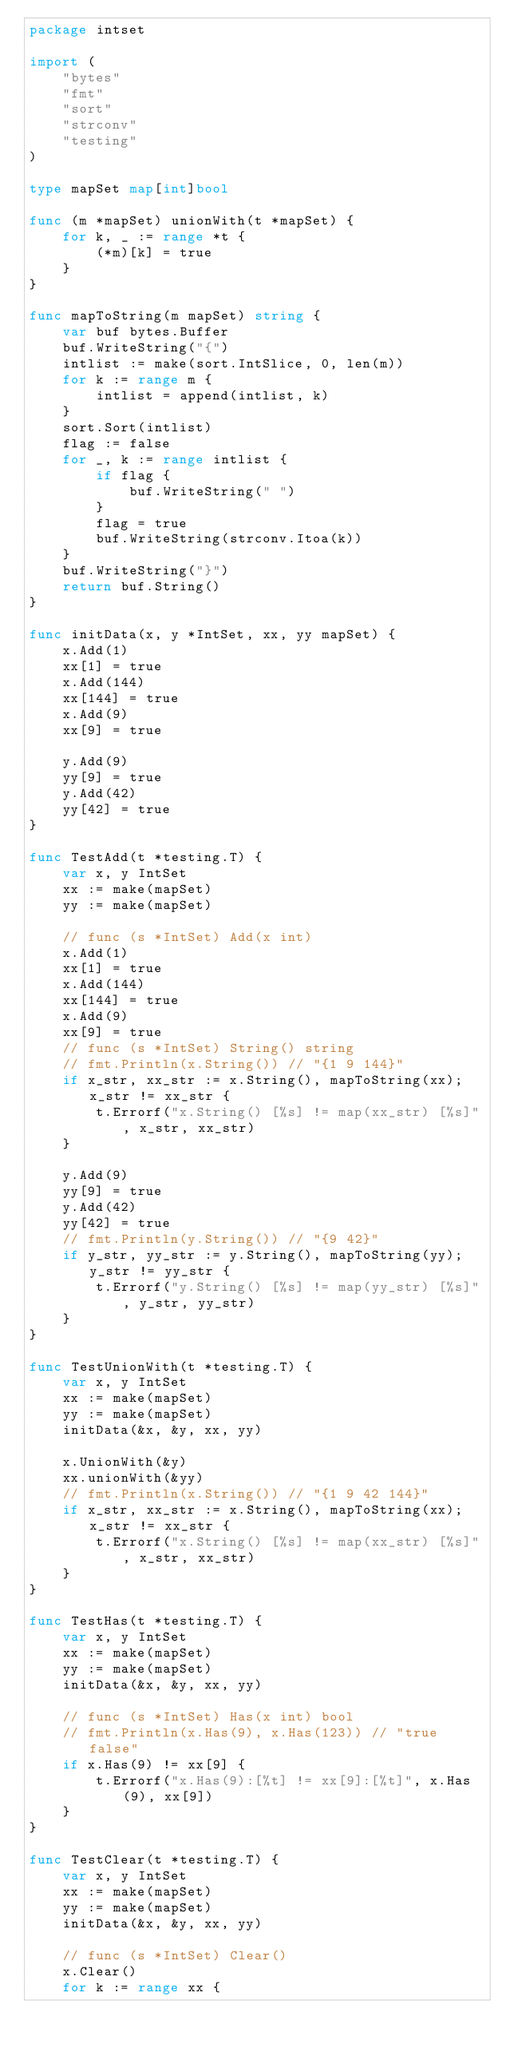Convert code to text. <code><loc_0><loc_0><loc_500><loc_500><_Go_>package intset

import (
	"bytes"
	"fmt"
	"sort"
	"strconv"
	"testing"
)

type mapSet map[int]bool

func (m *mapSet) unionWith(t *mapSet) {
	for k, _ := range *t {
		(*m)[k] = true
	}
}

func mapToString(m mapSet) string {
	var buf bytes.Buffer
	buf.WriteString("{")
	intlist := make(sort.IntSlice, 0, len(m))
	for k := range m {
		intlist = append(intlist, k)
	}
	sort.Sort(intlist)
	flag := false
	for _, k := range intlist {
		if flag {
			buf.WriteString(" ")
		}
		flag = true
		buf.WriteString(strconv.Itoa(k))
	}
	buf.WriteString("}")
	return buf.String()
}

func initData(x, y *IntSet, xx, yy mapSet) {
	x.Add(1)
	xx[1] = true
	x.Add(144)
	xx[144] = true
	x.Add(9)
	xx[9] = true

	y.Add(9)
	yy[9] = true
	y.Add(42)
	yy[42] = true
}

func TestAdd(t *testing.T) {
	var x, y IntSet
	xx := make(mapSet)
	yy := make(mapSet)

	// func (s *IntSet) Add(x int)
	x.Add(1)
	xx[1] = true
	x.Add(144)
	xx[144] = true
	x.Add(9)
	xx[9] = true
	// func (s *IntSet) String() string
	// fmt.Println(x.String()) // "{1 9 144}"
	if x_str, xx_str := x.String(), mapToString(xx); x_str != xx_str {
		t.Errorf("x.String() [%s] != map(xx_str) [%s]", x_str, xx_str)
	}

	y.Add(9)
	yy[9] = true
	y.Add(42)
	yy[42] = true
	// fmt.Println(y.String()) // "{9 42}"
	if y_str, yy_str := y.String(), mapToString(yy); y_str != yy_str {
		t.Errorf("y.String() [%s] != map(yy_str) [%s]", y_str, yy_str)
	}
}

func TestUnionWith(t *testing.T) {
	var x, y IntSet
	xx := make(mapSet)
	yy := make(mapSet)
	initData(&x, &y, xx, yy)

	x.UnionWith(&y)
	xx.unionWith(&yy)
	// fmt.Println(x.String()) // "{1 9 42 144}"
	if x_str, xx_str := x.String(), mapToString(xx); x_str != xx_str {
		t.Errorf("x.String() [%s] != map(xx_str) [%s]", x_str, xx_str)
	}
}

func TestHas(t *testing.T) {
	var x, y IntSet
	xx := make(mapSet)
	yy := make(mapSet)
	initData(&x, &y, xx, yy)

	// func (s *IntSet) Has(x int) bool
	// fmt.Println(x.Has(9), x.Has(123)) // "true false"
	if x.Has(9) != xx[9] {
		t.Errorf("x.Has(9):[%t] != xx[9]:[%t]", x.Has(9), xx[9])
	}
}

func TestClear(t *testing.T) {
	var x, y IntSet
	xx := make(mapSet)
	yy := make(mapSet)
	initData(&x, &y, xx, yy)

	// func (s *IntSet) Clear()
	x.Clear()
	for k := range xx {</code> 